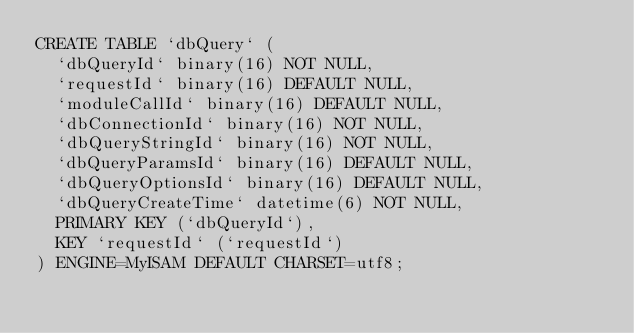<code> <loc_0><loc_0><loc_500><loc_500><_SQL_>CREATE TABLE `dbQuery` (
  `dbQueryId` binary(16) NOT NULL,
  `requestId` binary(16) DEFAULT NULL,
  `moduleCallId` binary(16) DEFAULT NULL,
  `dbConnectionId` binary(16) NOT NULL,
  `dbQueryStringId` binary(16) NOT NULL,
  `dbQueryParamsId` binary(16) DEFAULT NULL,
  `dbQueryOptionsId` binary(16) DEFAULT NULL,
  `dbQueryCreateTime` datetime(6) NOT NULL,
  PRIMARY KEY (`dbQueryId`),
  KEY `requestId` (`requestId`)
) ENGINE=MyISAM DEFAULT CHARSET=utf8;
</code> 